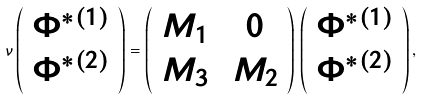Convert formula to latex. <formula><loc_0><loc_0><loc_500><loc_500>\nu \left ( \begin{array} { c } \Phi ^ { * ( 1 ) } \\ \Phi ^ { * ( 2 ) } \end{array} \right ) = \left ( \begin{array} { c c } M _ { 1 } & \, 0 \\ M _ { 3 } & \, M _ { 2 } \end{array} \right ) \, \left ( \begin{array} { c } \Phi ^ { * ( 1 ) } \\ \Phi ^ { * ( 2 ) } \end{array} \right ) ,</formula> 